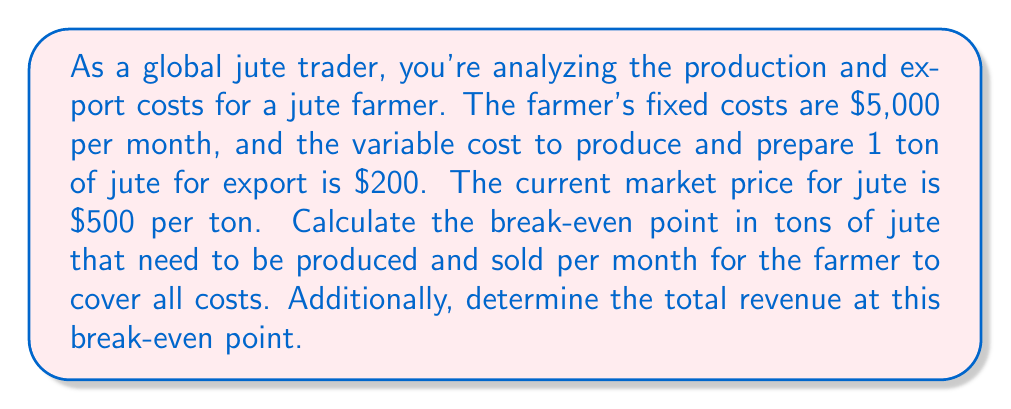Teach me how to tackle this problem. To solve this problem, we need to use the break-even formula and then calculate the total revenue at that point.

1. Let's define our variables:
   $FC$ = Fixed Costs = $5,000 per month
   $VC$ = Variable Costs = $200 per ton
   $P$ = Price = $500 per ton
   $Q$ = Quantity (in tons) at break-even point

2. The break-even formula is:
   $$ FC + VC \cdot Q = P \cdot Q $$

3. Substituting our values:
   $$ 5000 + 200Q = 500Q $$

4. Simplify:
   $$ 5000 = 500Q - 200Q = 300Q $$

5. Solve for Q:
   $$ Q = \frac{5000}{300} = \frac{50}{3} \approx 16.67 $$

   Since we can't sell a fraction of a ton, we round up to 17 tons.

6. To calculate total revenue at the break-even point:
   $$ \text{Total Revenue} = P \cdot Q = 500 \cdot 17 = 8500 $$

Therefore, the farmer needs to produce and sell 17 tons of jute per month to break even, and the total revenue at this point will be $8,500.
Answer: Break-even point: 17 tons of jute per month
Total revenue at break-even: $8,500 